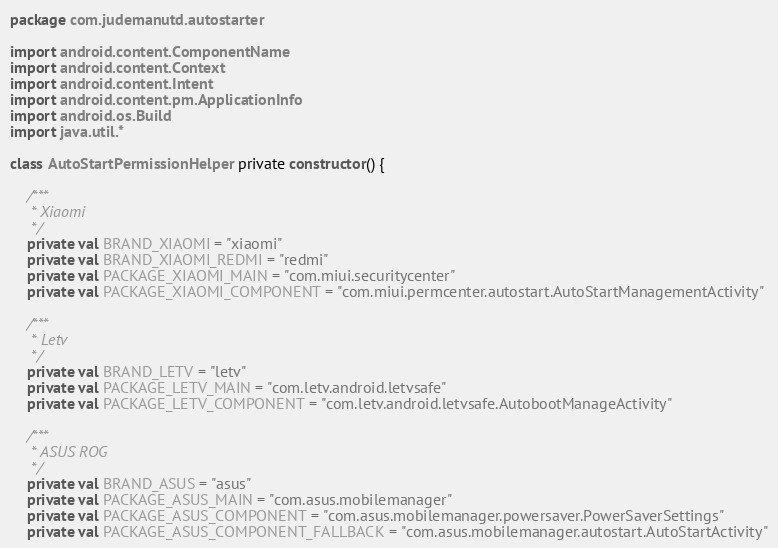<code> <loc_0><loc_0><loc_500><loc_500><_Kotlin_>package com.judemanutd.autostarter

import android.content.ComponentName
import android.content.Context
import android.content.Intent
import android.content.pm.ApplicationInfo
import android.os.Build
import java.util.*

class AutoStartPermissionHelper private constructor() {

    /***
     * Xiaomi
     */
    private val BRAND_XIAOMI = "xiaomi"
    private val BRAND_XIAOMI_REDMI = "redmi"
    private val PACKAGE_XIAOMI_MAIN = "com.miui.securitycenter"
    private val PACKAGE_XIAOMI_COMPONENT = "com.miui.permcenter.autostart.AutoStartManagementActivity"

    /***
     * Letv
     */
    private val BRAND_LETV = "letv"
    private val PACKAGE_LETV_MAIN = "com.letv.android.letvsafe"
    private val PACKAGE_LETV_COMPONENT = "com.letv.android.letvsafe.AutobootManageActivity"

    /***
     * ASUS ROG
     */
    private val BRAND_ASUS = "asus"
    private val PACKAGE_ASUS_MAIN = "com.asus.mobilemanager"
    private val PACKAGE_ASUS_COMPONENT = "com.asus.mobilemanager.powersaver.PowerSaverSettings"
    private val PACKAGE_ASUS_COMPONENT_FALLBACK = "com.asus.mobilemanager.autostart.AutoStartActivity"
</code> 